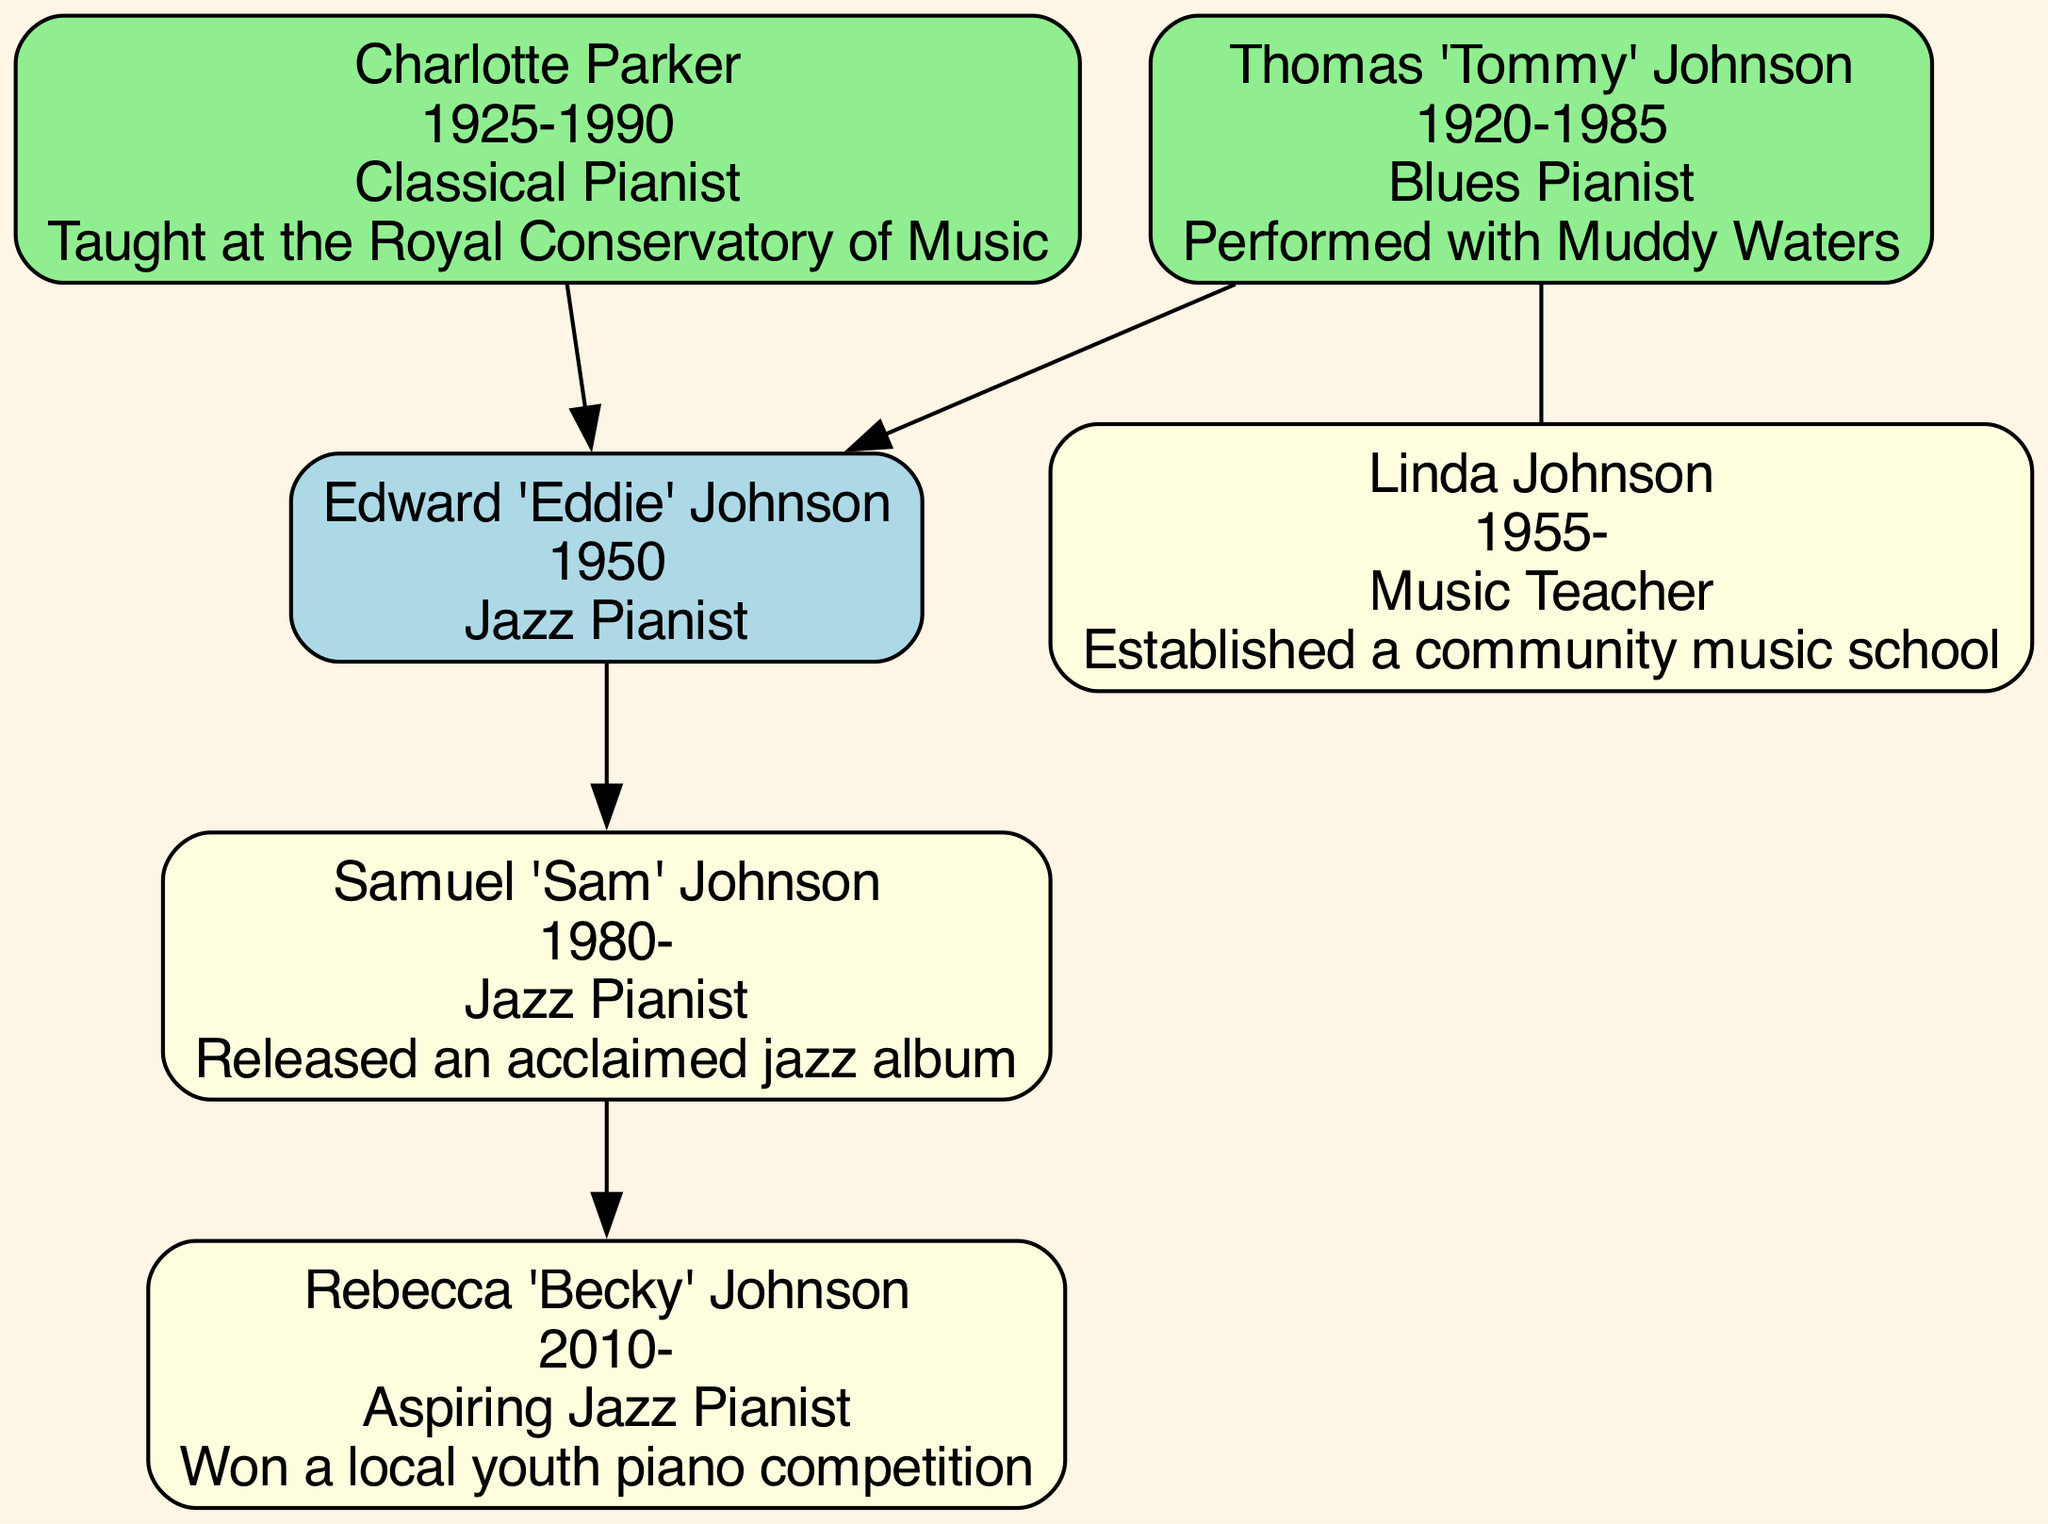What is the profession of Edward 'Eddie' Johnson? The diagram indicates that Edward 'Eddie' Johnson is a Jazz Pianist. This information is found directly under his name in the diagram.
Answer: Jazz Pianist Who is the father of Edward 'Eddie' Johnson? The father of Edward 'Eddie' Johnson is Thomas 'Tommy' Johnson. This relationship is explicitly labeled in the diagram and connected by a direct edge from the father to Eddie.
Answer: Thomas 'Tommy' Johnson How many generations are shown in this family tree? The diagram displays three generations: Edward, his parents (Thomas and Charlotte), and his children (Samuel and Rebecca). By counting the unique family members listed, we confirm there are three generations.
Answer: 3 What notable achievement is attributed to Charlotte Parker? The notable achievement of Charlotte Parker, the mother of Edward 'Eddie' Johnson, is that she taught at the Royal Conservatory of Music. This fact is noted in the text associated with her node in the diagram.
Answer: Taught at the Royal Conservatory of Music In which city does Samuel 'Sam' Johnson reside? Samuel 'Sam' Johnson resides in Montreal, Canada. This information is provided next to his name in the diagram, indicating his location.
Answer: Montreal, Canada Who performed with Muddy Waters? The person who performed with Muddy Waters is Thomas 'Tommy' Johnson. This is mentioned directly in the notable achievements section under his name in the diagram.
Answer: Thomas 'Tommy' Johnson How is Rebecca 'Becky' Johnson related to Edward 'Eddie' Johnson? Rebecca 'Becky' Johnson is the granddaughter of Edward 'Eddie' Johnson. This relationship is established as she is connected to him through the family tree.
Answer: Granddaughter What is the profession of Linda Johnson? The profession of Linda Johnson is Music Teacher. This is specified in her information in the diagram.
Answer: Music Teacher Which family member was born in 2010? The family member born in 2010 is Rebecca 'Becky' Johnson. This birth year is indicated next to her name in the diagram.
Answer: Rebecca 'Becky' Johnson 